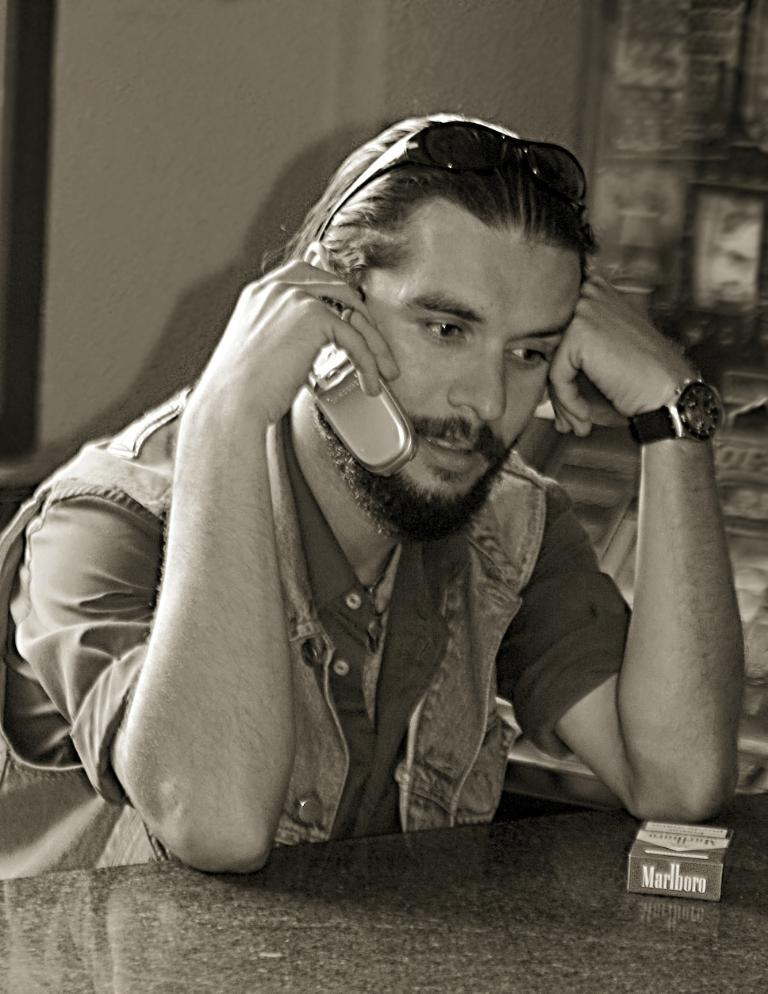What is the man in the image doing? The man is sitting in the image. What object is the man holding? The man is holding a phone. What is in front of the man? There is a table in front of the man. What can be seen in the background of the image? There is a wall in the background of the image. What type of bird is sitting on the man's shoulder in the image? There is no bird present in the image; the man is sitting alone with a phone. 